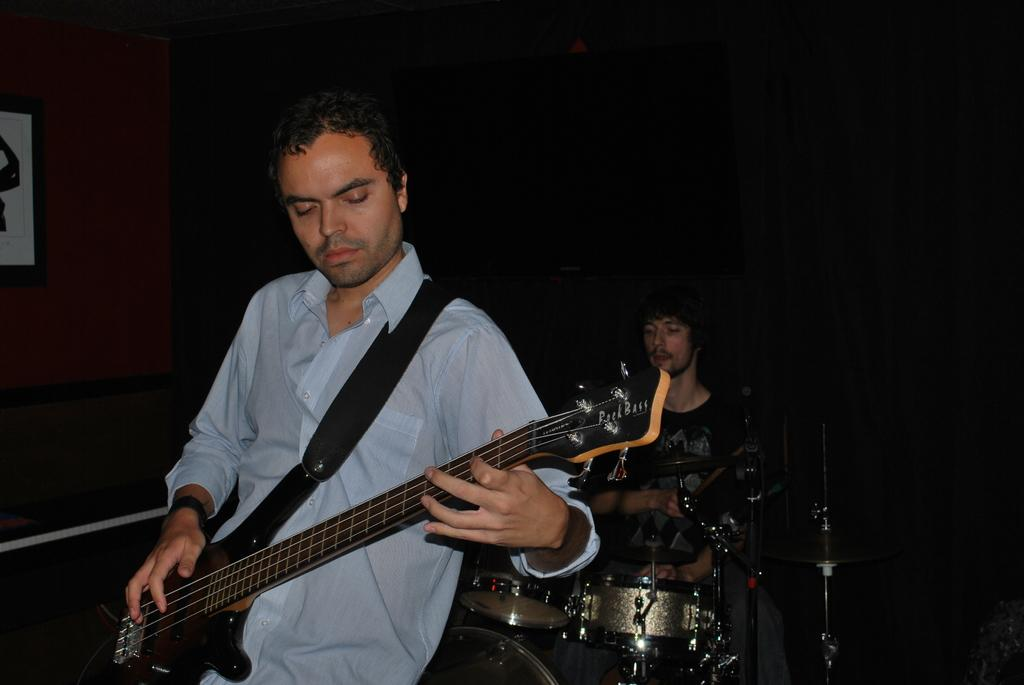What is the main activity being performed by the man in the image? The man is playing a guitar in the image. Are there any other musicians in the image? Yes, another person is playing musical instruments in the image. What can be inferred about the lighting conditions in the image? The background of the image is dark. Where is the image located? The image is on a wall. What is the plot of the story involving the creature in the image? There is no story or creature present in the image; it features a man playing a guitar and another person playing musical instruments. 